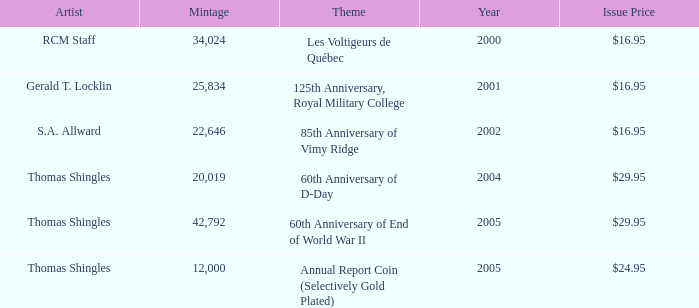What was the total mintage for years after 2002 that had a 85th Anniversary of Vimy Ridge theme? 0.0. 